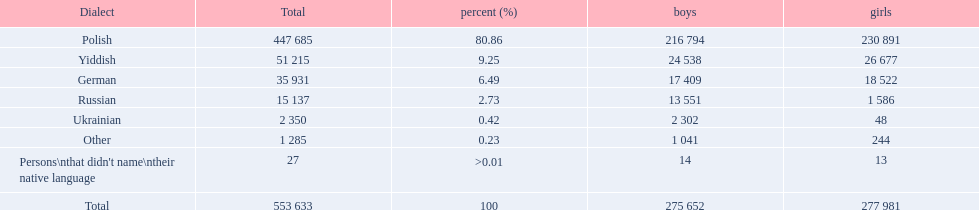What are all of the languages? Polish, Yiddish, German, Russian, Ukrainian, Other, Persons\nthat didn't name\ntheir native language. And how many people speak these languages? 447 685, 51 215, 35 931, 15 137, 2 350, 1 285, 27. Which language is used by most people? Polish. 